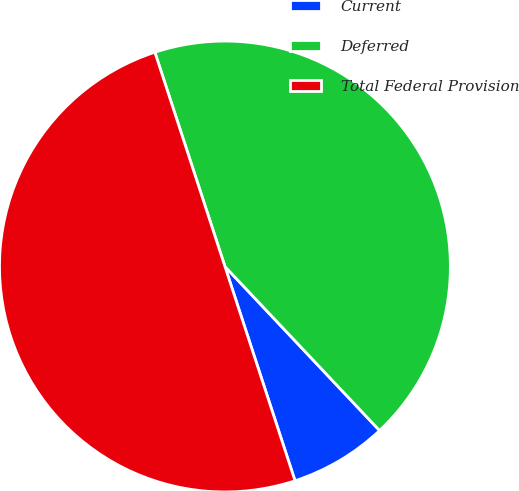Convert chart. <chart><loc_0><loc_0><loc_500><loc_500><pie_chart><fcel>Current<fcel>Deferred<fcel>Total Federal Provision<nl><fcel>7.0%<fcel>43.0%<fcel>50.0%<nl></chart> 